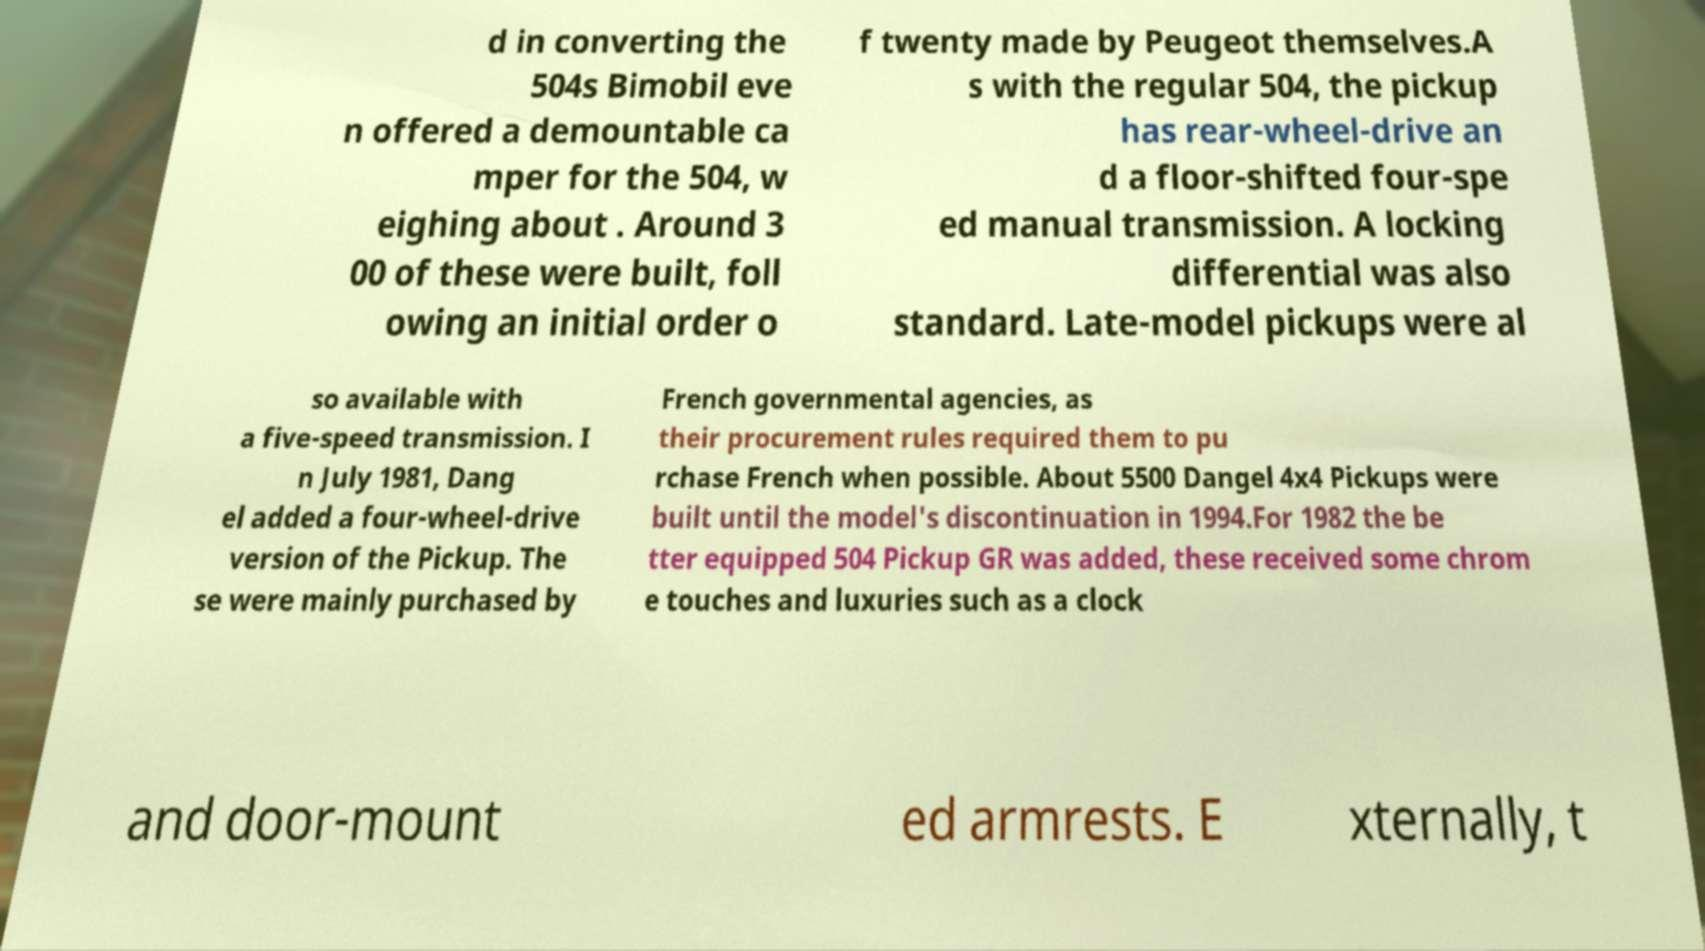Please read and relay the text visible in this image. What does it say? d in converting the 504s Bimobil eve n offered a demountable ca mper for the 504, w eighing about . Around 3 00 of these were built, foll owing an initial order o f twenty made by Peugeot themselves.A s with the regular 504, the pickup has rear-wheel-drive an d a floor-shifted four-spe ed manual transmission. A locking differential was also standard. Late-model pickups were al so available with a five-speed transmission. I n July 1981, Dang el added a four-wheel-drive version of the Pickup. The se were mainly purchased by French governmental agencies, as their procurement rules required them to pu rchase French when possible. About 5500 Dangel 4x4 Pickups were built until the model's discontinuation in 1994.For 1982 the be tter equipped 504 Pickup GR was added, these received some chrom e touches and luxuries such as a clock and door-mount ed armrests. E xternally, t 